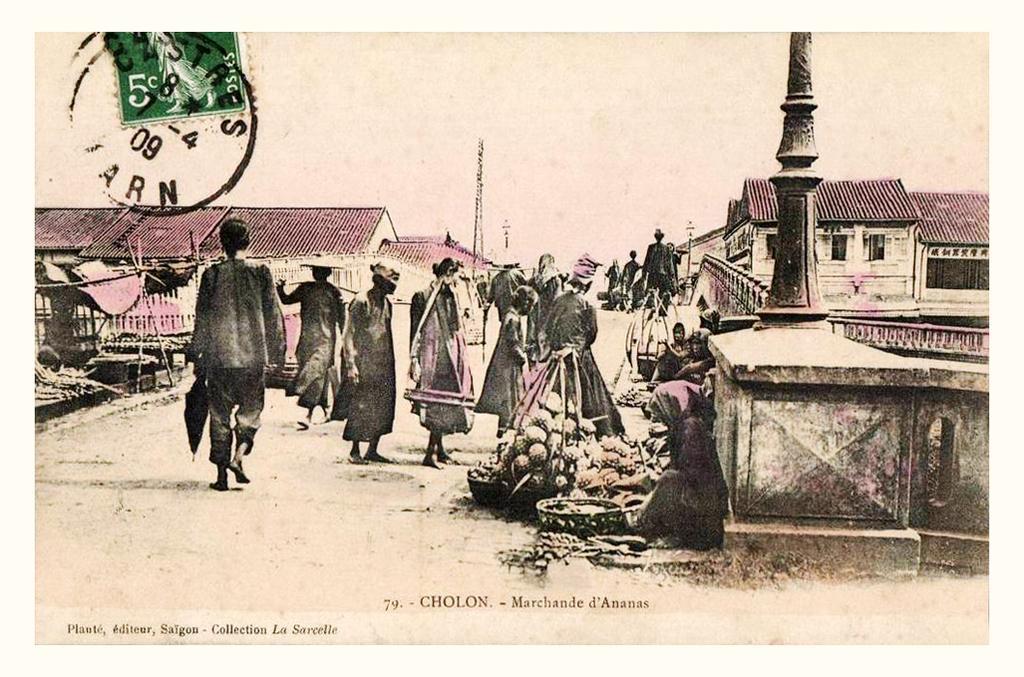In one or two sentences, can you explain what this image depicts? It looks like an edited image, in this image in the center there are some persons walking and some of them are sitting and selling some vegetables. On the right side and left side there are some houses, poles and on the left side there is a stamp. At the bottom of the image there is some text. 